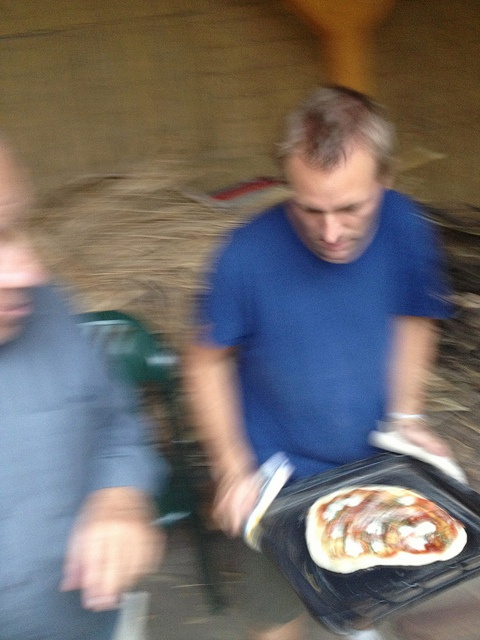Describe the objects in this image and their specific colors. I can see people in olive, blue, navy, tan, and gray tones, people in olive, darkgray, and gray tones, chair in olive, black, gray, and teal tones, and pizza in olive, ivory, and tan tones in this image. 